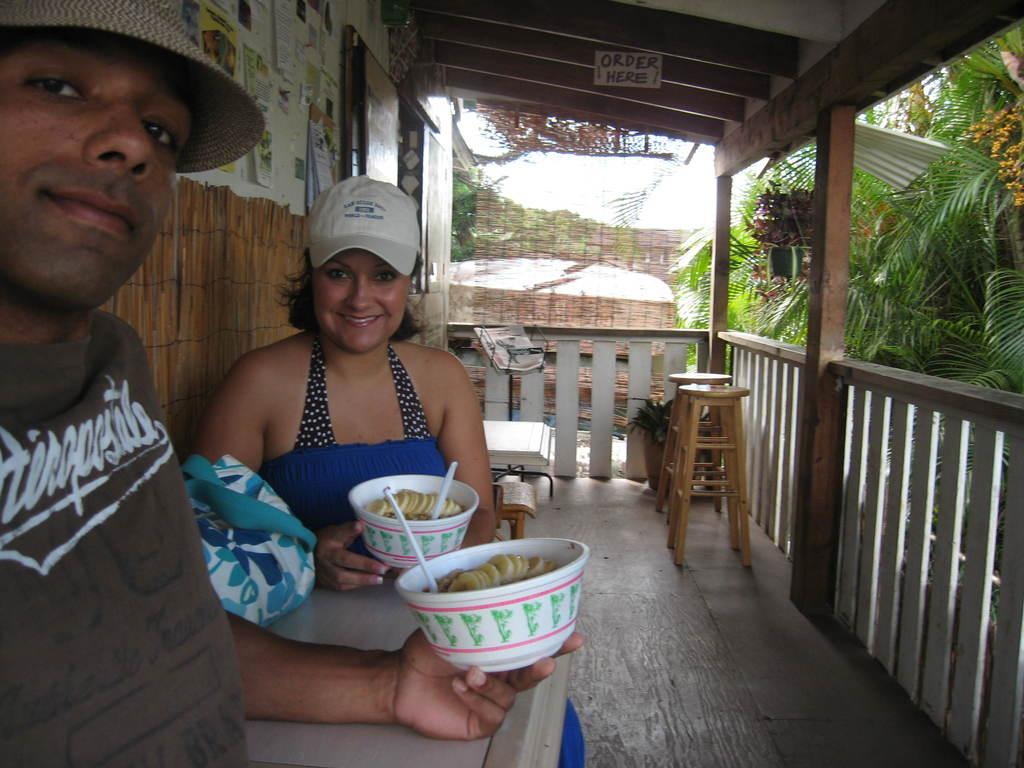What can be seen in the background of the image? There is a sky in the image, along with trees and a building. Can you describe the people in the image? There are two people sitting in the front, and they are holding bowls in their hands. What type of truck is parked next to the building in the image? There is no truck present in the image; it only features a sky, trees, building, and two people holding bowls. 